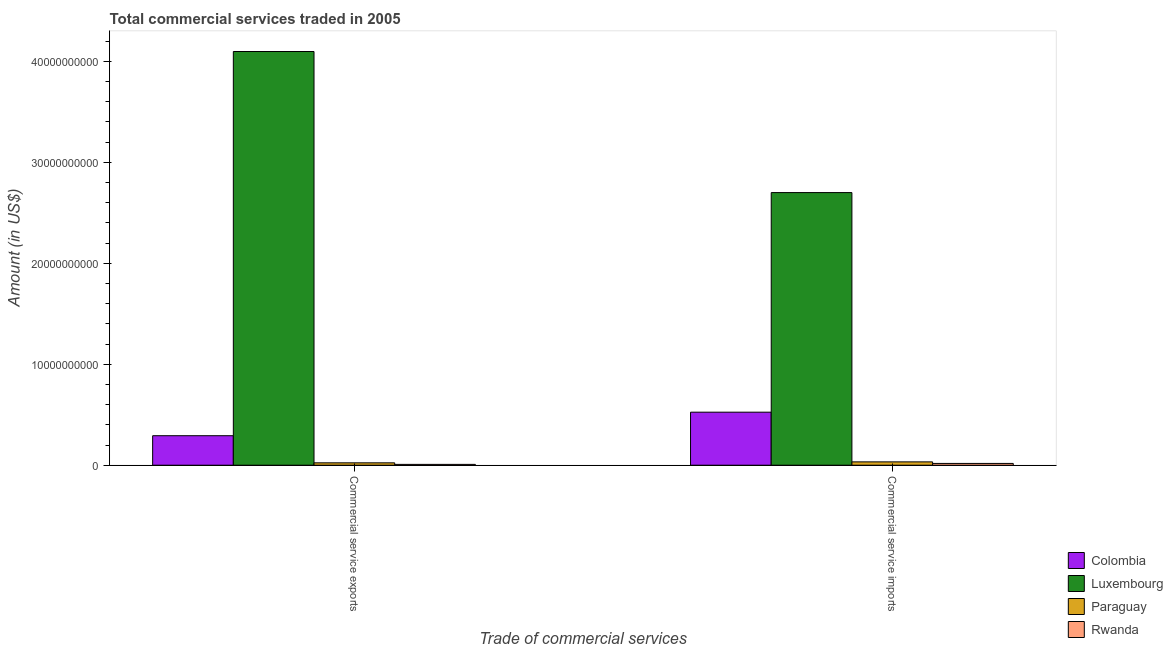How many different coloured bars are there?
Your response must be concise. 4. How many groups of bars are there?
Your answer should be compact. 2. Are the number of bars per tick equal to the number of legend labels?
Offer a very short reply. Yes. Are the number of bars on each tick of the X-axis equal?
Your response must be concise. Yes. How many bars are there on the 2nd tick from the right?
Provide a succinct answer. 4. What is the label of the 1st group of bars from the left?
Provide a short and direct response. Commercial service exports. What is the amount of commercial service exports in Paraguay?
Offer a very short reply. 2.35e+08. Across all countries, what is the maximum amount of commercial service imports?
Provide a succinct answer. 2.70e+1. Across all countries, what is the minimum amount of commercial service imports?
Make the answer very short. 1.75e+08. In which country was the amount of commercial service imports maximum?
Provide a succinct answer. Luxembourg. In which country was the amount of commercial service exports minimum?
Make the answer very short. Rwanda. What is the total amount of commercial service exports in the graph?
Your answer should be compact. 4.42e+1. What is the difference between the amount of commercial service exports in Paraguay and that in Colombia?
Offer a very short reply. -2.69e+09. What is the difference between the amount of commercial service exports in Paraguay and the amount of commercial service imports in Colombia?
Give a very brief answer. -5.02e+09. What is the average amount of commercial service exports per country?
Provide a succinct answer. 1.11e+1. What is the difference between the amount of commercial service imports and amount of commercial service exports in Luxembourg?
Your answer should be compact. -1.40e+1. What is the ratio of the amount of commercial service exports in Paraguay to that in Rwanda?
Provide a short and direct response. 2.86. Is the amount of commercial service exports in Rwanda less than that in Colombia?
Give a very brief answer. Yes. What does the 3rd bar from the right in Commercial service exports represents?
Your answer should be very brief. Luxembourg. How many bars are there?
Ensure brevity in your answer.  8. How many countries are there in the graph?
Provide a short and direct response. 4. What is the difference between two consecutive major ticks on the Y-axis?
Offer a very short reply. 1.00e+1. Are the values on the major ticks of Y-axis written in scientific E-notation?
Your answer should be compact. No. Does the graph contain any zero values?
Provide a short and direct response. No. Does the graph contain grids?
Your answer should be compact. No. Where does the legend appear in the graph?
Offer a very short reply. Bottom right. How many legend labels are there?
Give a very brief answer. 4. How are the legend labels stacked?
Offer a terse response. Vertical. What is the title of the graph?
Offer a very short reply. Total commercial services traded in 2005. What is the label or title of the X-axis?
Your answer should be very brief. Trade of commercial services. What is the Amount (in US$) in Colombia in Commercial service exports?
Your answer should be very brief. 2.92e+09. What is the Amount (in US$) of Luxembourg in Commercial service exports?
Make the answer very short. 4.10e+1. What is the Amount (in US$) of Paraguay in Commercial service exports?
Give a very brief answer. 2.35e+08. What is the Amount (in US$) in Rwanda in Commercial service exports?
Provide a short and direct response. 8.22e+07. What is the Amount (in US$) in Colombia in Commercial service imports?
Your answer should be very brief. 5.25e+09. What is the Amount (in US$) in Luxembourg in Commercial service imports?
Make the answer very short. 2.70e+1. What is the Amount (in US$) of Paraguay in Commercial service imports?
Ensure brevity in your answer.  3.29e+08. What is the Amount (in US$) of Rwanda in Commercial service imports?
Ensure brevity in your answer.  1.75e+08. Across all Trade of commercial services, what is the maximum Amount (in US$) in Colombia?
Your response must be concise. 5.25e+09. Across all Trade of commercial services, what is the maximum Amount (in US$) in Luxembourg?
Your answer should be compact. 4.10e+1. Across all Trade of commercial services, what is the maximum Amount (in US$) in Paraguay?
Provide a short and direct response. 3.29e+08. Across all Trade of commercial services, what is the maximum Amount (in US$) of Rwanda?
Make the answer very short. 1.75e+08. Across all Trade of commercial services, what is the minimum Amount (in US$) in Colombia?
Keep it short and to the point. 2.92e+09. Across all Trade of commercial services, what is the minimum Amount (in US$) in Luxembourg?
Make the answer very short. 2.70e+1. Across all Trade of commercial services, what is the minimum Amount (in US$) of Paraguay?
Ensure brevity in your answer.  2.35e+08. Across all Trade of commercial services, what is the minimum Amount (in US$) in Rwanda?
Offer a terse response. 8.22e+07. What is the total Amount (in US$) in Colombia in the graph?
Your answer should be compact. 8.17e+09. What is the total Amount (in US$) of Luxembourg in the graph?
Offer a very short reply. 6.80e+1. What is the total Amount (in US$) of Paraguay in the graph?
Ensure brevity in your answer.  5.64e+08. What is the total Amount (in US$) in Rwanda in the graph?
Give a very brief answer. 2.58e+08. What is the difference between the Amount (in US$) in Colombia in Commercial service exports and that in Commercial service imports?
Keep it short and to the point. -2.33e+09. What is the difference between the Amount (in US$) in Luxembourg in Commercial service exports and that in Commercial service imports?
Provide a succinct answer. 1.40e+1. What is the difference between the Amount (in US$) in Paraguay in Commercial service exports and that in Commercial service imports?
Ensure brevity in your answer.  -9.40e+07. What is the difference between the Amount (in US$) in Rwanda in Commercial service exports and that in Commercial service imports?
Your answer should be compact. -9.33e+07. What is the difference between the Amount (in US$) of Colombia in Commercial service exports and the Amount (in US$) of Luxembourg in Commercial service imports?
Your response must be concise. -2.41e+1. What is the difference between the Amount (in US$) of Colombia in Commercial service exports and the Amount (in US$) of Paraguay in Commercial service imports?
Your answer should be compact. 2.59e+09. What is the difference between the Amount (in US$) of Colombia in Commercial service exports and the Amount (in US$) of Rwanda in Commercial service imports?
Offer a very short reply. 2.75e+09. What is the difference between the Amount (in US$) in Luxembourg in Commercial service exports and the Amount (in US$) in Paraguay in Commercial service imports?
Ensure brevity in your answer.  4.06e+1. What is the difference between the Amount (in US$) in Luxembourg in Commercial service exports and the Amount (in US$) in Rwanda in Commercial service imports?
Provide a short and direct response. 4.08e+1. What is the difference between the Amount (in US$) in Paraguay in Commercial service exports and the Amount (in US$) in Rwanda in Commercial service imports?
Provide a short and direct response. 5.97e+07. What is the average Amount (in US$) of Colombia per Trade of commercial services?
Offer a very short reply. 4.09e+09. What is the average Amount (in US$) of Luxembourg per Trade of commercial services?
Keep it short and to the point. 3.40e+1. What is the average Amount (in US$) in Paraguay per Trade of commercial services?
Your response must be concise. 2.82e+08. What is the average Amount (in US$) in Rwanda per Trade of commercial services?
Provide a succinct answer. 1.29e+08. What is the difference between the Amount (in US$) of Colombia and Amount (in US$) of Luxembourg in Commercial service exports?
Offer a terse response. -3.81e+1. What is the difference between the Amount (in US$) in Colombia and Amount (in US$) in Paraguay in Commercial service exports?
Your response must be concise. 2.69e+09. What is the difference between the Amount (in US$) in Colombia and Amount (in US$) in Rwanda in Commercial service exports?
Your response must be concise. 2.84e+09. What is the difference between the Amount (in US$) in Luxembourg and Amount (in US$) in Paraguay in Commercial service exports?
Your answer should be very brief. 4.07e+1. What is the difference between the Amount (in US$) in Luxembourg and Amount (in US$) in Rwanda in Commercial service exports?
Ensure brevity in your answer.  4.09e+1. What is the difference between the Amount (in US$) of Paraguay and Amount (in US$) of Rwanda in Commercial service exports?
Your answer should be compact. 1.53e+08. What is the difference between the Amount (in US$) of Colombia and Amount (in US$) of Luxembourg in Commercial service imports?
Provide a succinct answer. -2.18e+1. What is the difference between the Amount (in US$) in Colombia and Amount (in US$) in Paraguay in Commercial service imports?
Provide a succinct answer. 4.92e+09. What is the difference between the Amount (in US$) of Colombia and Amount (in US$) of Rwanda in Commercial service imports?
Your answer should be very brief. 5.08e+09. What is the difference between the Amount (in US$) in Luxembourg and Amount (in US$) in Paraguay in Commercial service imports?
Give a very brief answer. 2.67e+1. What is the difference between the Amount (in US$) of Luxembourg and Amount (in US$) of Rwanda in Commercial service imports?
Your answer should be compact. 2.68e+1. What is the difference between the Amount (in US$) of Paraguay and Amount (in US$) of Rwanda in Commercial service imports?
Your answer should be very brief. 1.54e+08. What is the ratio of the Amount (in US$) in Colombia in Commercial service exports to that in Commercial service imports?
Your answer should be compact. 0.56. What is the ratio of the Amount (in US$) of Luxembourg in Commercial service exports to that in Commercial service imports?
Your answer should be compact. 1.52. What is the ratio of the Amount (in US$) of Paraguay in Commercial service exports to that in Commercial service imports?
Provide a short and direct response. 0.71. What is the ratio of the Amount (in US$) in Rwanda in Commercial service exports to that in Commercial service imports?
Ensure brevity in your answer.  0.47. What is the difference between the highest and the second highest Amount (in US$) of Colombia?
Provide a succinct answer. 2.33e+09. What is the difference between the highest and the second highest Amount (in US$) in Luxembourg?
Your response must be concise. 1.40e+1. What is the difference between the highest and the second highest Amount (in US$) of Paraguay?
Give a very brief answer. 9.40e+07. What is the difference between the highest and the second highest Amount (in US$) of Rwanda?
Your answer should be compact. 9.33e+07. What is the difference between the highest and the lowest Amount (in US$) of Colombia?
Provide a short and direct response. 2.33e+09. What is the difference between the highest and the lowest Amount (in US$) of Luxembourg?
Give a very brief answer. 1.40e+1. What is the difference between the highest and the lowest Amount (in US$) in Paraguay?
Make the answer very short. 9.40e+07. What is the difference between the highest and the lowest Amount (in US$) of Rwanda?
Your answer should be compact. 9.33e+07. 